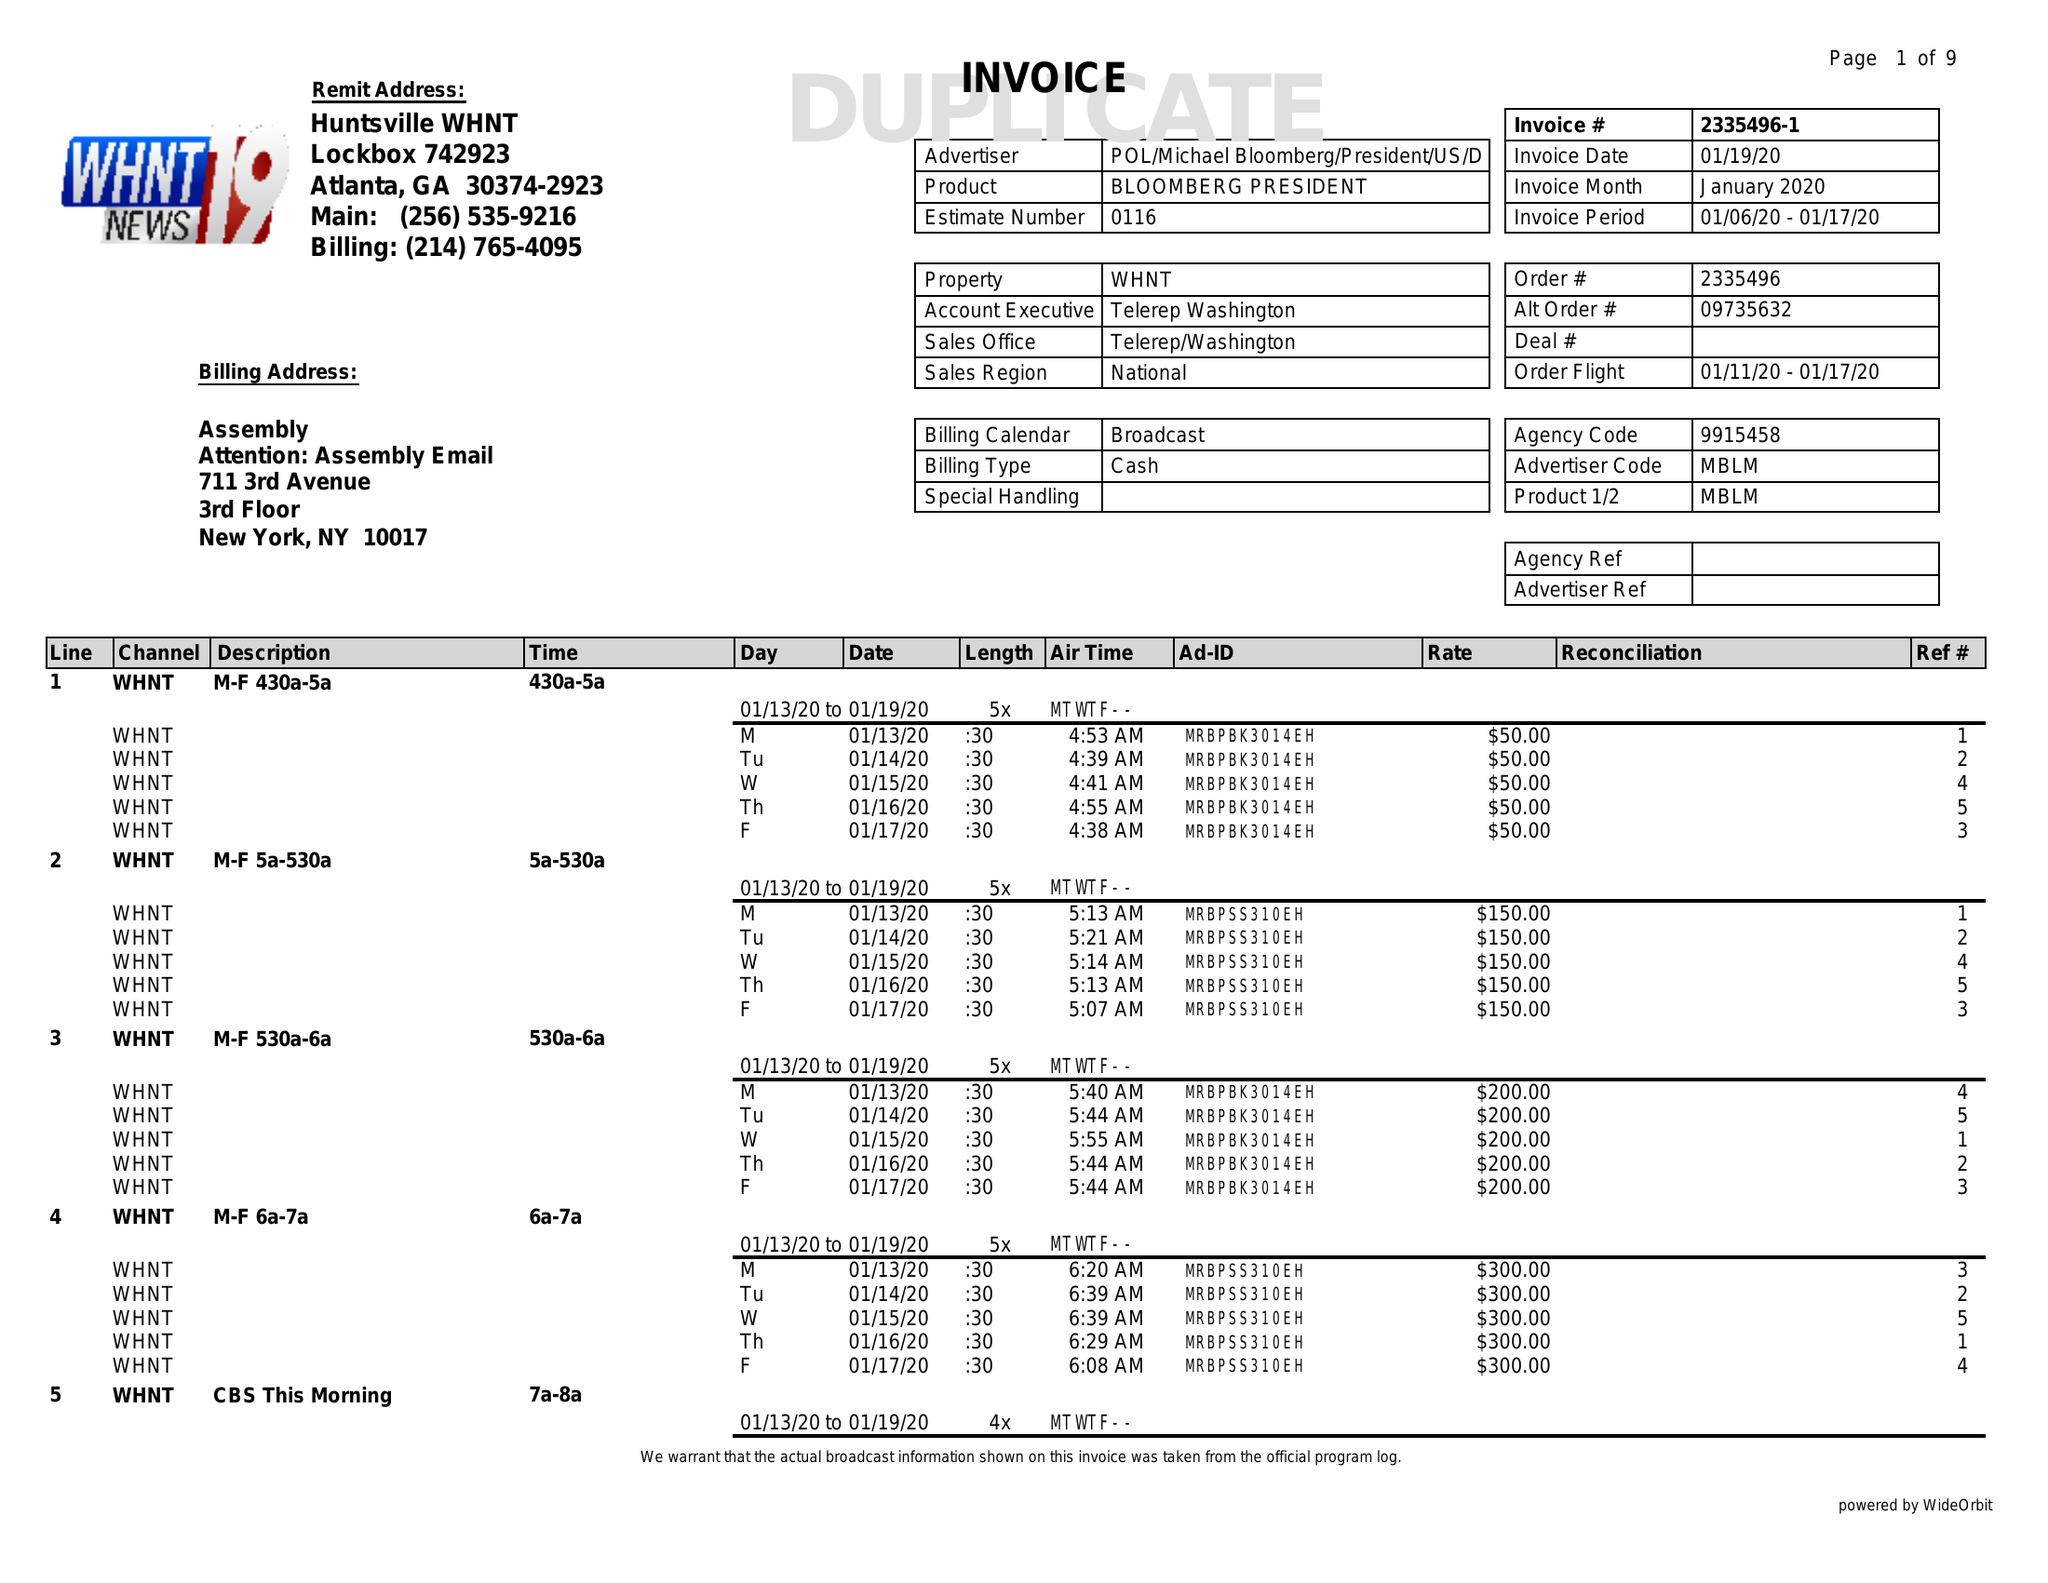What is the value for the advertiser?
Answer the question using a single word or phrase. POL/MICHAELBLOOMBERG/PRESIDENT/US/ 